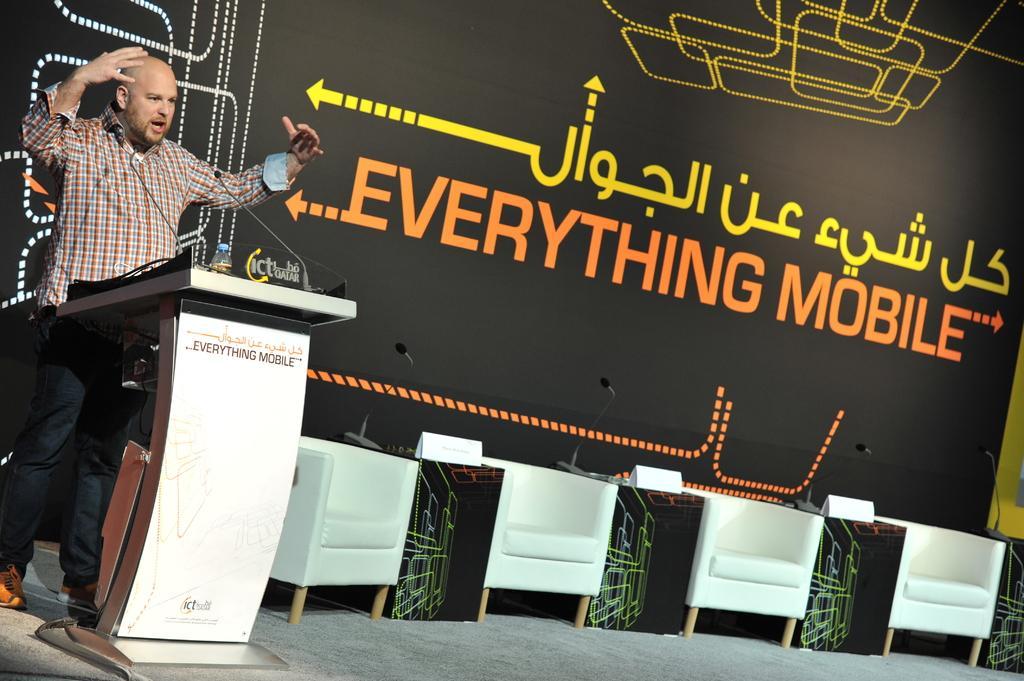How would you summarize this image in a sentence or two? In this picture a man is talking with a mic in front of him and there are unoccupied beside him. In the background there is a poster named everything mobile. 